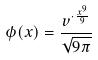<formula> <loc_0><loc_0><loc_500><loc_500>\phi ( x ) = \frac { v ^ { \cdot \frac { x ^ { 9 } } { 9 } } } { \sqrt { 9 \pi } }</formula> 